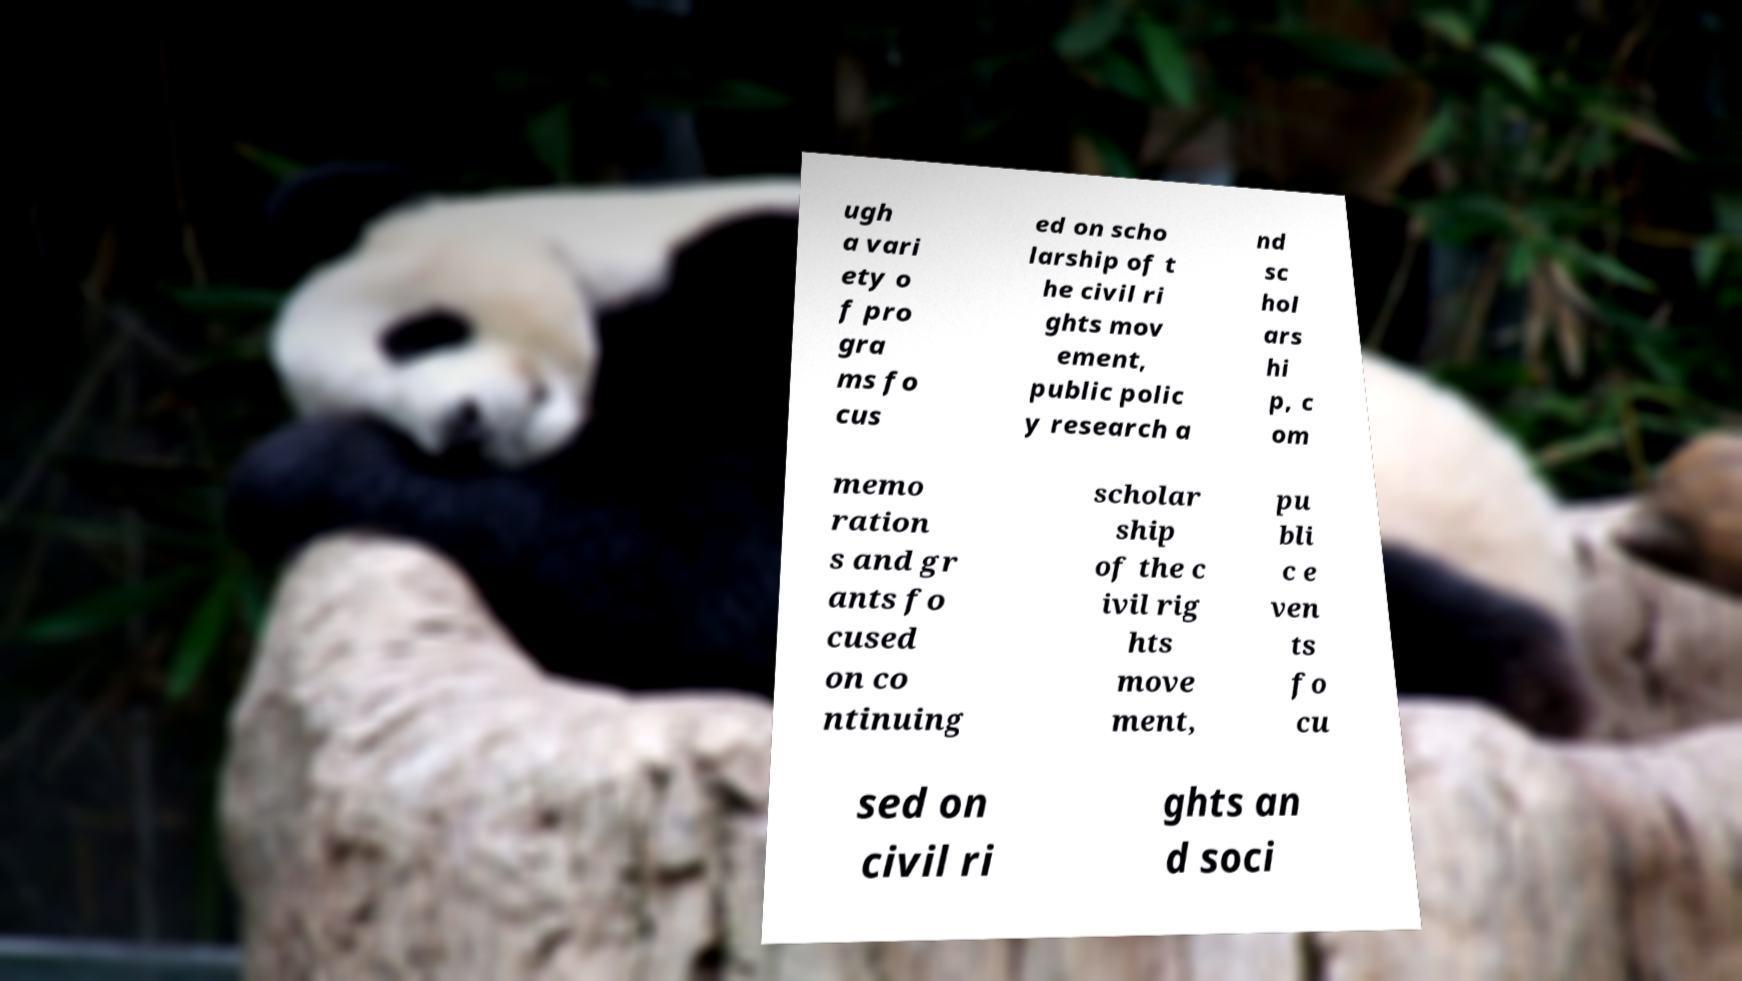Please identify and transcribe the text found in this image. ugh a vari ety o f pro gra ms fo cus ed on scho larship of t he civil ri ghts mov ement, public polic y research a nd sc hol ars hi p, c om memo ration s and gr ants fo cused on co ntinuing scholar ship of the c ivil rig hts move ment, pu bli c e ven ts fo cu sed on civil ri ghts an d soci 